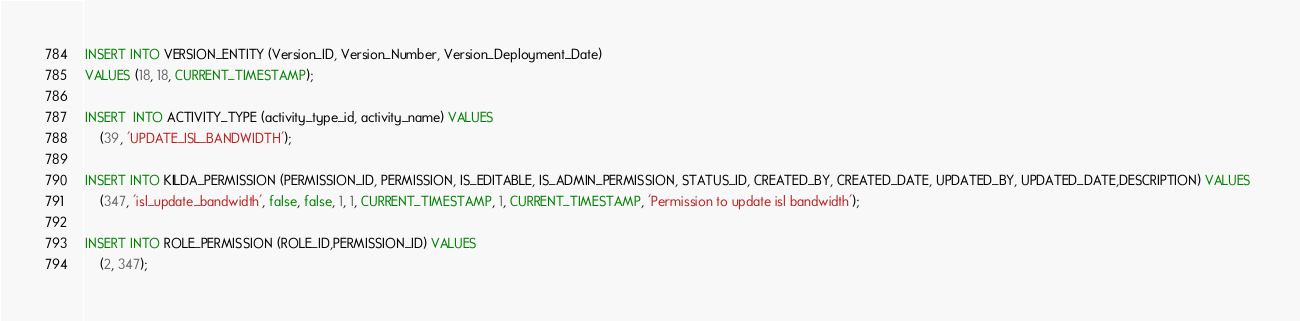<code> <loc_0><loc_0><loc_500><loc_500><_SQL_>INSERT INTO VERSION_ENTITY (Version_ID, Version_Number, Version_Deployment_Date)
VALUES (18, 18, CURRENT_TIMESTAMP);
	
INSERT  INTO ACTIVITY_TYPE (activity_type_id, activity_name) VALUES 
	(39, 'UPDATE_ISL_BANDWIDTH');

INSERT INTO KILDA_PERMISSION (PERMISSION_ID, PERMISSION, IS_EDITABLE, IS_ADMIN_PERMISSION, STATUS_ID, CREATED_BY, CREATED_DATE, UPDATED_BY, UPDATED_DATE,DESCRIPTION) VALUES 
	(347, 'isl_update_bandwidth', false, false, 1, 1, CURRENT_TIMESTAMP, 1, CURRENT_TIMESTAMP, 'Permission to update isl bandwidth');
	
INSERT INTO ROLE_PERMISSION (ROLE_ID,PERMISSION_ID) VALUES 
	(2, 347);</code> 